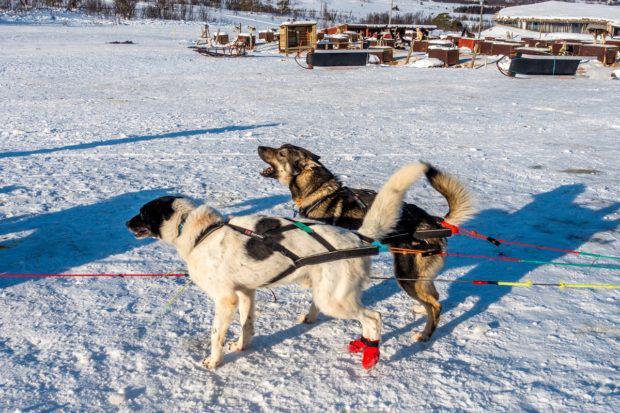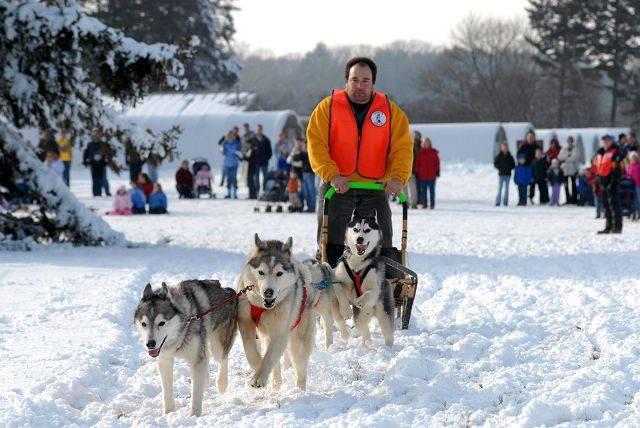The first image is the image on the left, the second image is the image on the right. Considering the images on both sides, is "There are two huskies strapped next to each other on the snow." valid? Answer yes or no. Yes. The first image is the image on the left, the second image is the image on the right. Examine the images to the left and right. Is the description "In the right image, crowds of people are standing behind a dog sled team driven by a man in a vest and headed forward." accurate? Answer yes or no. Yes. 